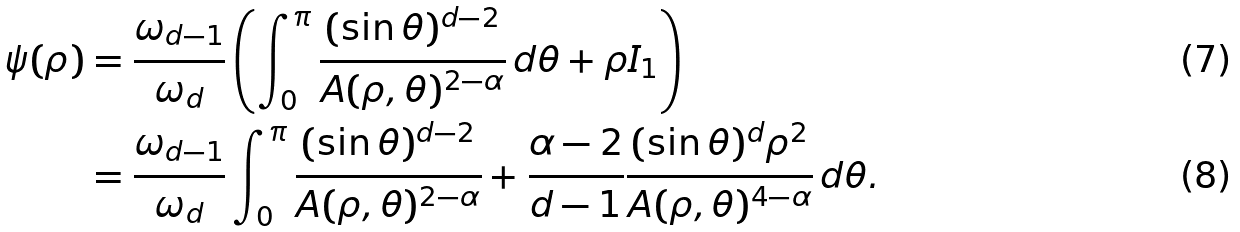<formula> <loc_0><loc_0><loc_500><loc_500>\psi ( \rho ) & = \frac { \omega _ { d - 1 } } { \omega _ { d } } \left ( \int _ { 0 } ^ { \pi } \frac { ( \sin \theta ) ^ { d - 2 } } { A ( \rho , \theta ) ^ { 2 - \alpha } } \, d \theta + \rho I _ { 1 } \right ) \\ & = \frac { \omega _ { d - 1 } } { \omega _ { d } } \int _ { 0 } ^ { \pi } \frac { ( \sin \theta ) ^ { d - 2 } } { A ( \rho , \theta ) ^ { 2 - \alpha } } + \frac { \alpha - 2 } { d - 1 } \frac { ( \sin \theta ) ^ { d } \rho ^ { 2 } } { A ( \rho , \theta ) ^ { 4 - \alpha } } \, d \theta .</formula> 